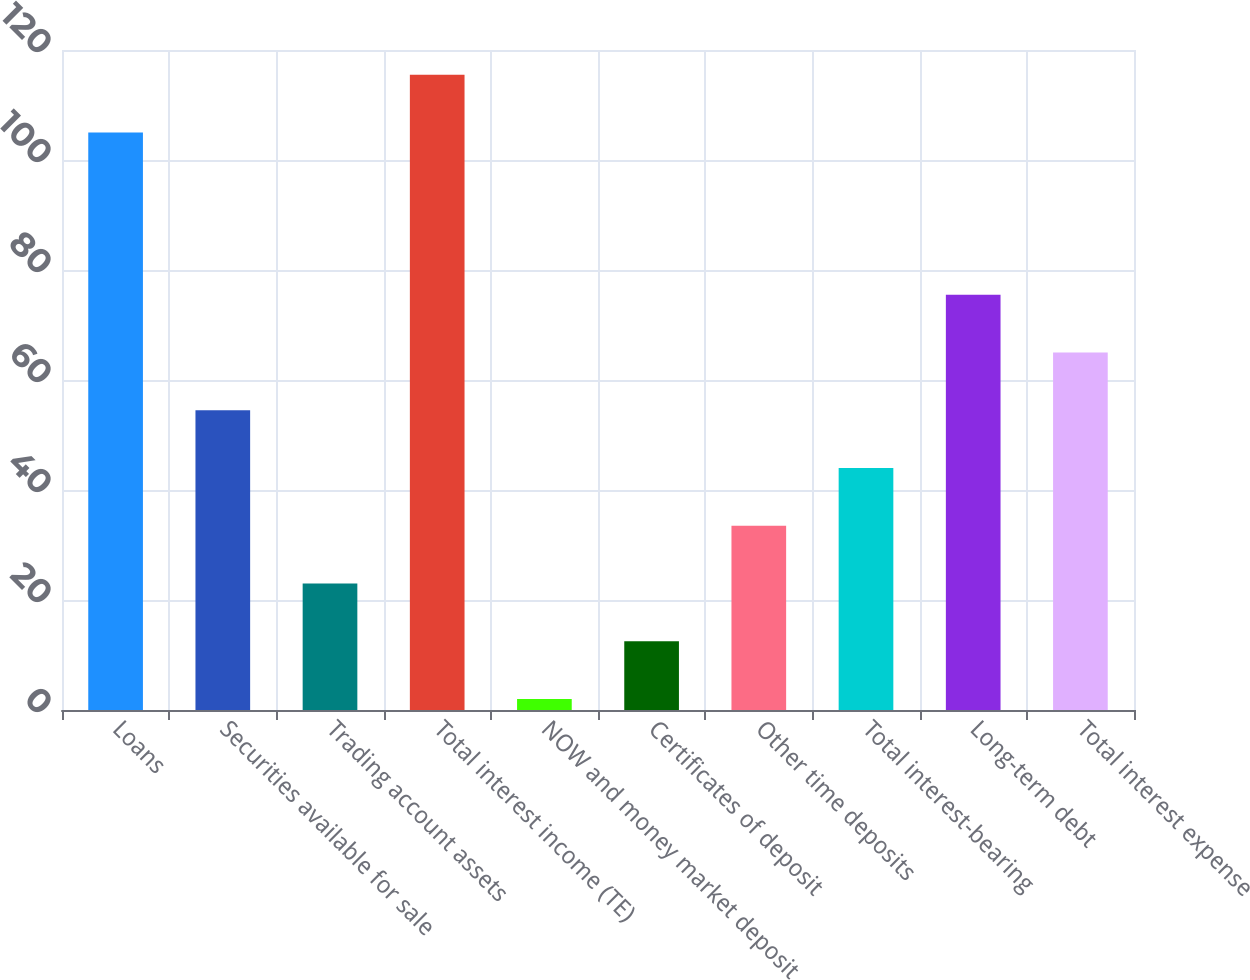Convert chart to OTSL. <chart><loc_0><loc_0><loc_500><loc_500><bar_chart><fcel>Loans<fcel>Securities available for sale<fcel>Trading account assets<fcel>Total interest income (TE)<fcel>NOW and money market deposit<fcel>Certificates of deposit<fcel>Other time deposits<fcel>Total interest-bearing<fcel>Long-term debt<fcel>Total interest expense<nl><fcel>105<fcel>54.5<fcel>23<fcel>115.5<fcel>2<fcel>12.5<fcel>33.5<fcel>44<fcel>75.5<fcel>65<nl></chart> 